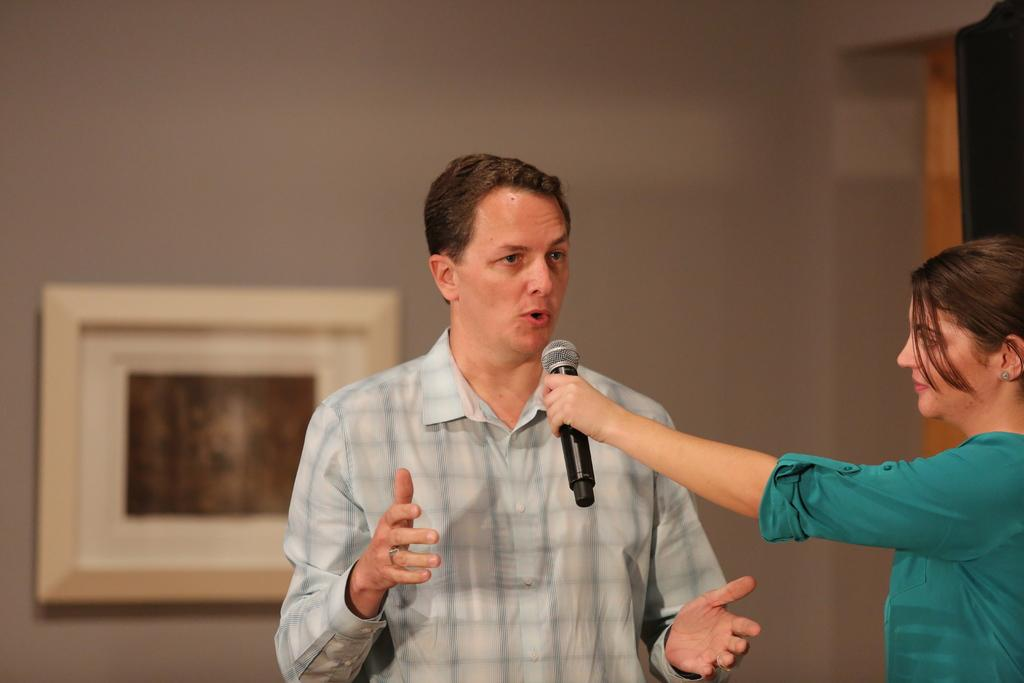What is the man in the image doing? The man is talking on a mic. How is the man holding the mic? The man is holding the mic. What can be seen behind the man? There is a wall behind the man. What is on the wall behind the man? There is a frame on the wall. How many flies are buzzing around the man's head in the image? There are no flies present in the image. What type of pail is the man using to collect his thoughts while talking on the mic? There is no pail present in the image, and the man is not using any object to collect his thoughts. 